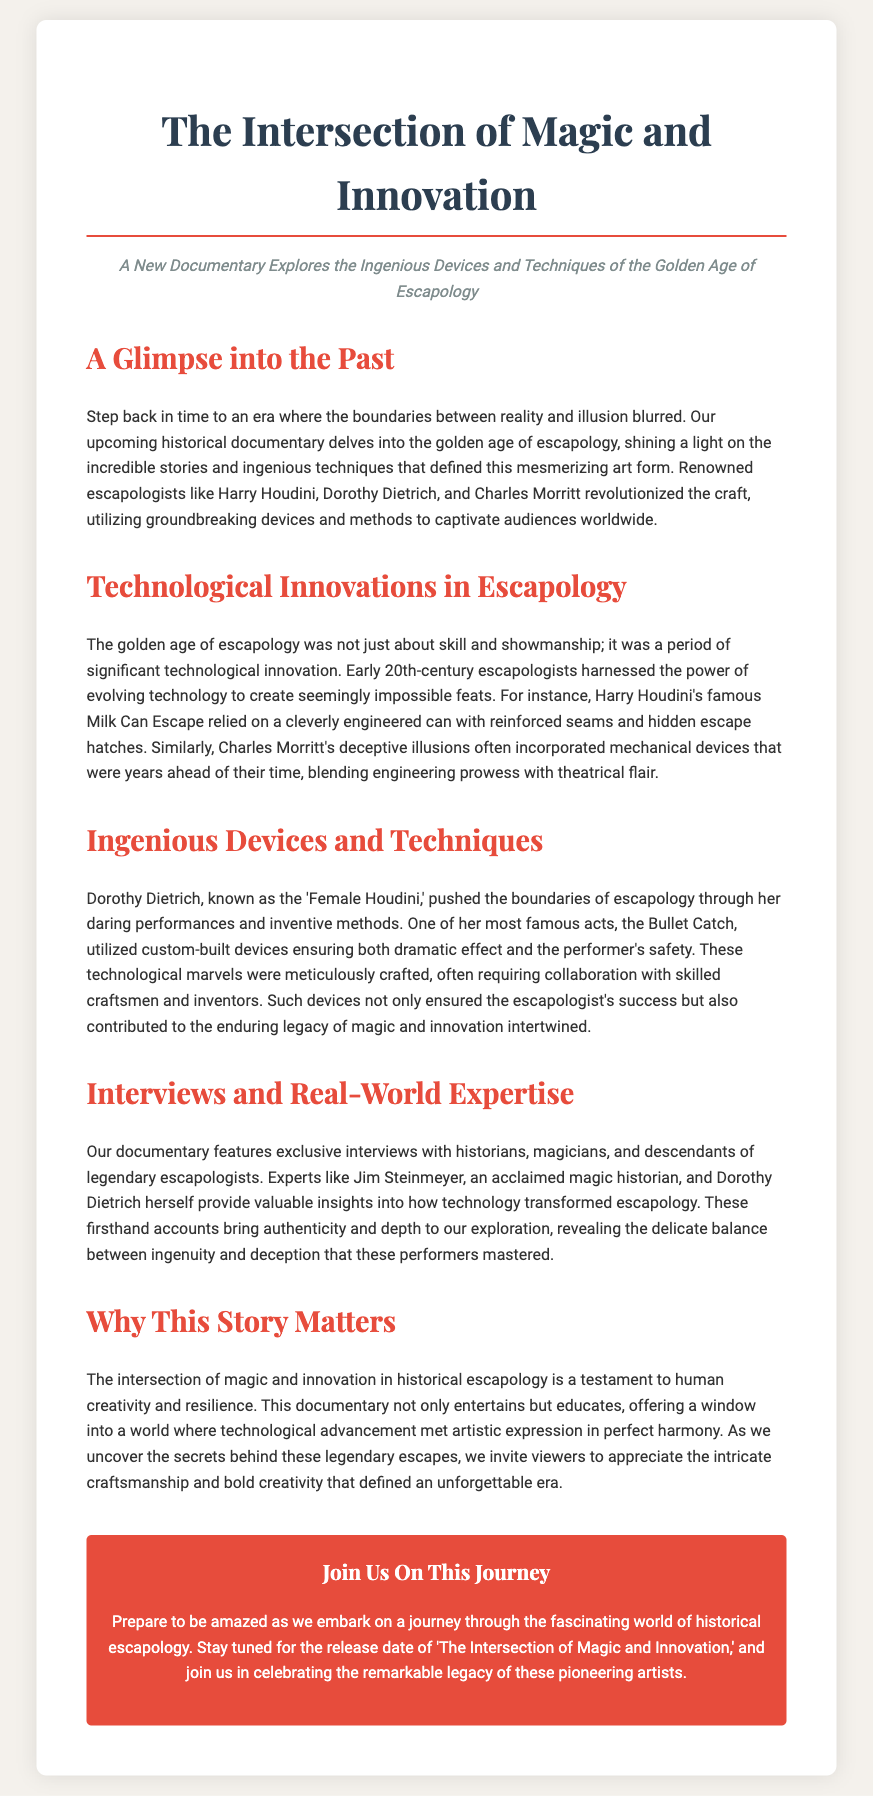What is the title of the documentary? The title of the documentary is clearly stated at the top of the document.
Answer: The Intersection of Magic and Innovation Who is known as the 'Female Houdini'? The document highlights Dorothy Dietrich as the individual known by this title.
Answer: Dorothy Dietrich What famous act did Dorothy Dietrich perform? The document mentions one of her most famous acts as a significant example of her work.
Answer: Bullet Catch Who is an acclaimed magic historian featured in the documentary? The press release lists a specific individual as an expert in magic history.
Answer: Jim Steinmeyer What era does the documentary focus on? The document references a specific period in the history of escapology being explored.
Answer: Golden Age of Escapology What was a significant technological innovation used by Houdini in his escapology acts? The document provides information on a specific innovation associated with Houdini's performances.
Answer: Milk Can Escape How does the documentary contribute to the understanding of escapology? The press release explains the purpose of the documentary in relation to escapology.
Answer: It educates What type of interviews are featured in the documentary? The document mentions the kind of individuals being interviewed to add depth to the story.
Answer: Exclusive interviews 